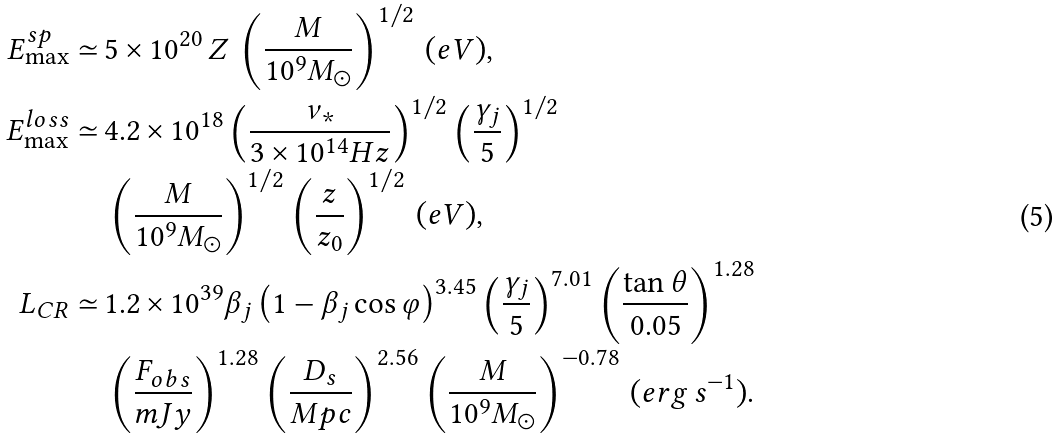<formula> <loc_0><loc_0><loc_500><loc_500>E _ { \max } ^ { s p } \simeq \, & 5 \times 1 0 ^ { 2 0 } \, Z \, \left ( \frac { M } { 1 0 ^ { 9 } M _ { \odot } } \right ) ^ { 1 / 2 } \, ( e V ) , \\ E _ { \max } ^ { l o s s } \simeq \, & 4 . 2 \times 1 0 ^ { 1 8 } \left ( \frac { \nu _ { * } } { 3 \times 1 0 ^ { 1 4 } H z } \right ) ^ { 1 / 2 } \left ( \frac { \gamma _ { j } } { 5 } \right ) ^ { 1 / 2 } \\ & \left ( \frac { M } { 1 0 ^ { 9 } M _ { \odot } } \right ) ^ { 1 / 2 } \left ( \frac { z } { z _ { 0 } } \right ) ^ { 1 / 2 } \, ( e V ) , \\ L _ { C R } \simeq \, & 1 . 2 \times 1 0 ^ { 3 9 } \beta _ { j } \left ( 1 - \beta _ { j } \cos \varphi \right ) ^ { 3 . 4 5 } \left ( \frac { \gamma _ { j } } { 5 } \right ) ^ { 7 . 0 1 } \left ( \frac { \tan \theta } { 0 . 0 5 } \right ) ^ { 1 . 2 8 } \\ & \left ( \frac { F _ { o b s } } { m J y } \right ) ^ { 1 . 2 8 } \left ( \frac { D _ { s } } { M p c } \right ) ^ { 2 . 5 6 } \left ( \frac { M } { 1 0 ^ { 9 } M _ { \odot } } \right ) ^ { - 0 . 7 8 } \, ( e r g \, s ^ { - 1 } ) .</formula> 